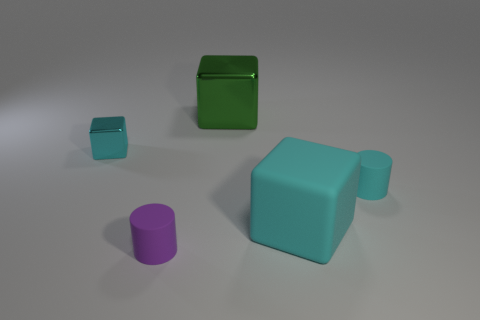Add 3 cyan matte objects. How many objects exist? 8 Subtract all cylinders. How many objects are left? 3 Add 5 small cyan shiny objects. How many small cyan shiny objects exist? 6 Subtract 0 blue cylinders. How many objects are left? 5 Subtract all large blue spheres. Subtract all large rubber objects. How many objects are left? 4 Add 2 big green objects. How many big green objects are left? 3 